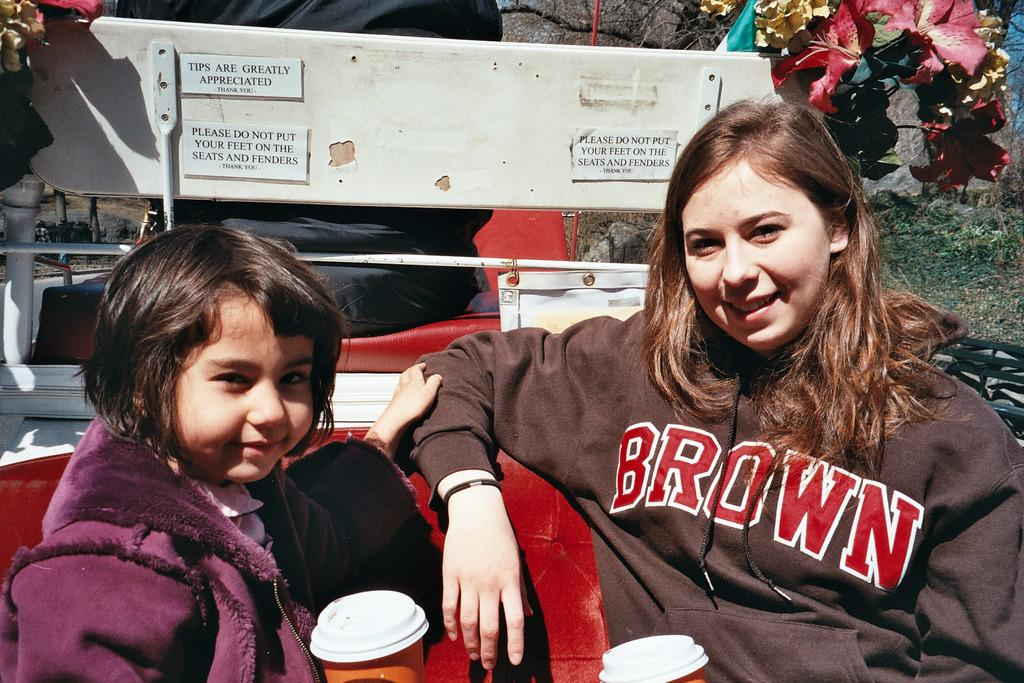<image>
Give a short and clear explanation of the subsequent image. A child sits next to a girl wearing a sweatshirt with "Brown" on the front. 